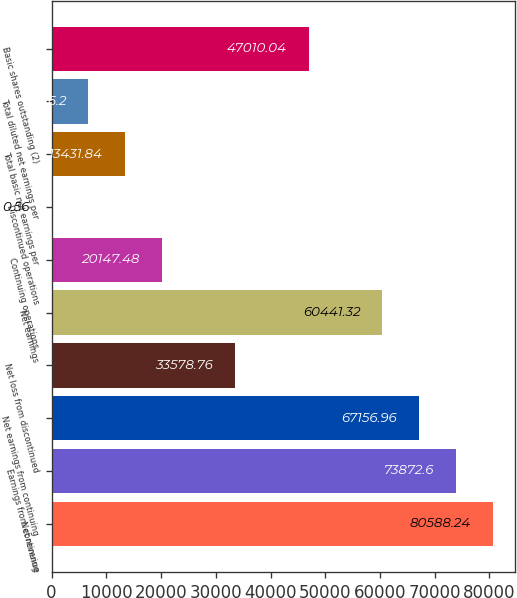Convert chart to OTSL. <chart><loc_0><loc_0><loc_500><loc_500><bar_chart><fcel>Net revenue<fcel>Earnings from continuing<fcel>Net earnings from continuing<fcel>Net loss from discontinued<fcel>Net earnings<fcel>Continuing operations<fcel>Discontinued operations<fcel>Total basic net earnings per<fcel>Total diluted net earnings per<fcel>Basic shares outstanding (2)<nl><fcel>80588.2<fcel>73872.6<fcel>67157<fcel>33578.8<fcel>60441.3<fcel>20147.5<fcel>0.56<fcel>13431.8<fcel>6716.2<fcel>47010<nl></chart> 